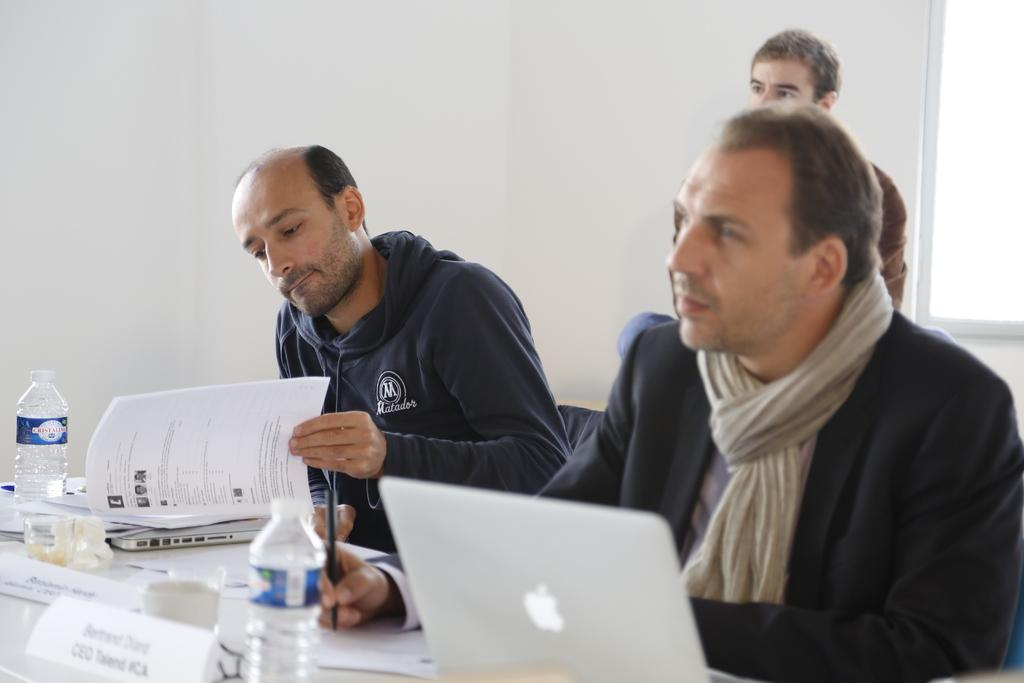How many men are sitting in the image? There are three men sitting in the image. What can be seen on the table in the image? There are bottles, laptops, and papers on the table. Are there any other objects on the table? Yes, there are other objects on the table. What is visible in the background of the image? There is a wall and a window in the background of the image. What type of cakes are being served to the achiever in the image? There are no cakes or achievers present in the image. What town is visible through the window in the image? The image does not show a town through the window; it only shows a wall and a window in the background. 